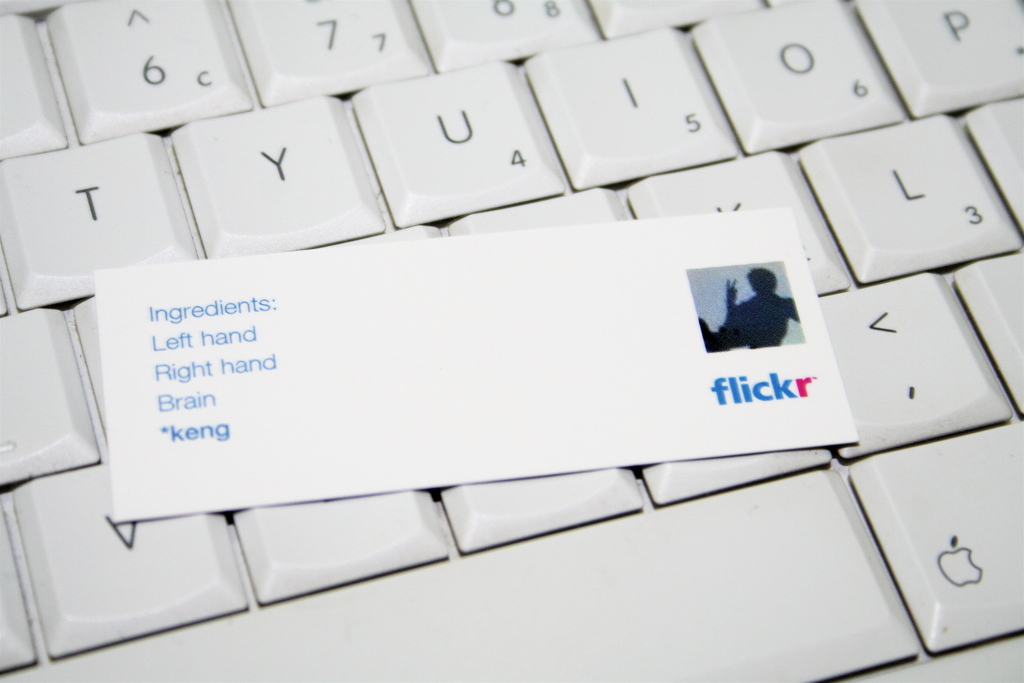What could the word 'keng' on the card mean in this context? The word 'keng' could be a personal nickname, a specific project code, or an artistic pseudonym utilized by the creator. It adds a layer of personalization or mystery to the card, suggesting a unique element or signature contribution of the individual to their creative process. 